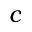<formula> <loc_0><loc_0><loc_500><loc_500>c</formula> 